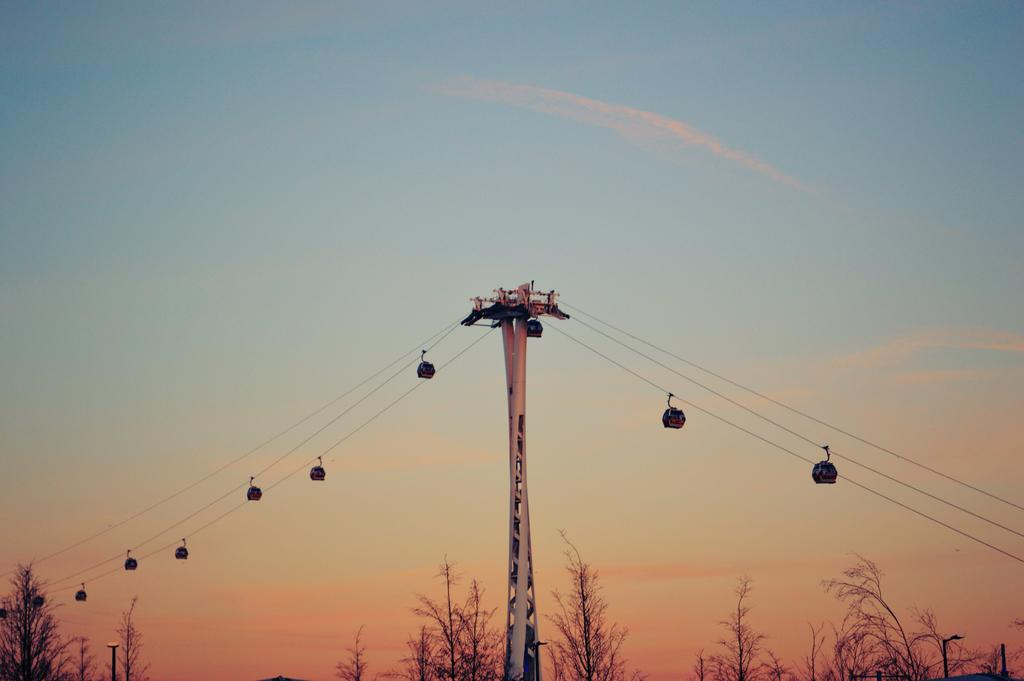What is the main subject in the center of the image? There are cable cars in the center of the image. What type of vegetation can be seen at the bottom side of the image? There are plants at the bottom side of the image. What is visible at the top side of the image? There is sky visible at the top side of the image. What type of glass is used to construct the cable cars in the image? There is no mention of glass being used in the construction of the cable cars in the image. 